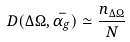<formula> <loc_0><loc_0><loc_500><loc_500>D ( \Delta \Omega , \bar { \alpha _ { g } } ) \simeq \frac { n _ { \Delta \Omega } } { N }</formula> 